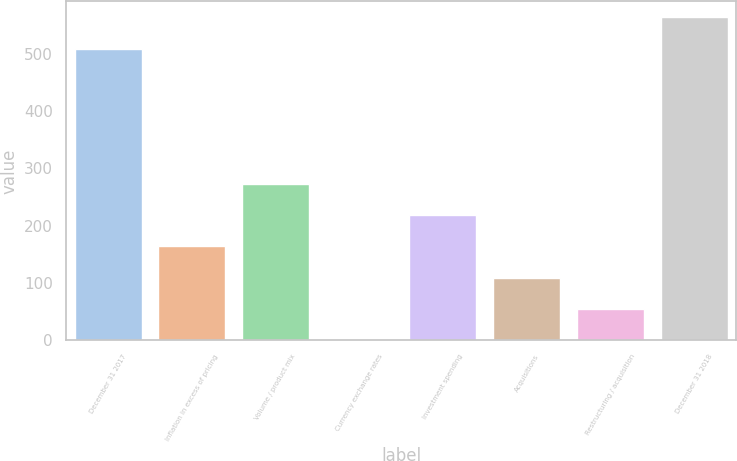<chart> <loc_0><loc_0><loc_500><loc_500><bar_chart><fcel>December 31 2017<fcel>Inflation in excess of pricing<fcel>Volume / product mix<fcel>Currency exchange rates<fcel>Investment spending<fcel>Acquisitions<fcel>Restructuring / acquisition<fcel>December 31 2018<nl><fcel>508.5<fcel>163.84<fcel>272.6<fcel>0.7<fcel>218.22<fcel>109.46<fcel>55.08<fcel>562.88<nl></chart> 